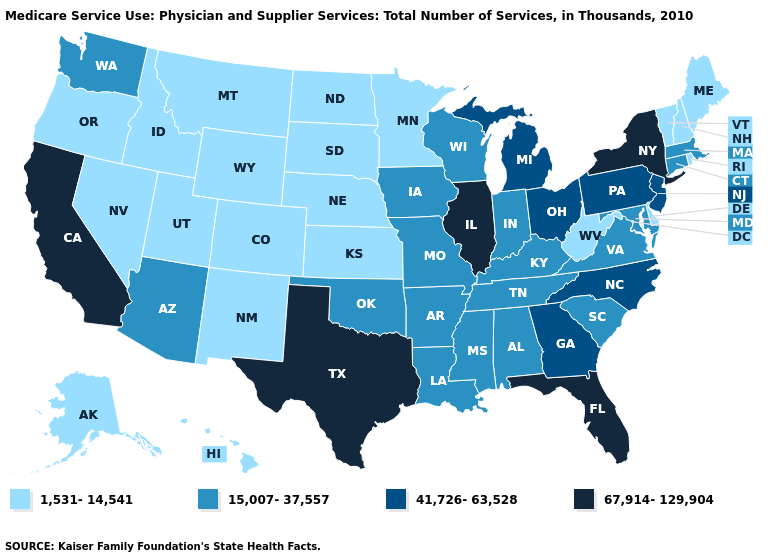What is the value of Missouri?
Write a very short answer. 15,007-37,557. Name the states that have a value in the range 15,007-37,557?
Concise answer only. Alabama, Arizona, Arkansas, Connecticut, Indiana, Iowa, Kentucky, Louisiana, Maryland, Massachusetts, Mississippi, Missouri, Oklahoma, South Carolina, Tennessee, Virginia, Washington, Wisconsin. Does the map have missing data?
Short answer required. No. Name the states that have a value in the range 41,726-63,528?
Answer briefly. Georgia, Michigan, New Jersey, North Carolina, Ohio, Pennsylvania. What is the value of Maryland?
Answer briefly. 15,007-37,557. What is the value of North Dakota?
Quick response, please. 1,531-14,541. Name the states that have a value in the range 15,007-37,557?
Short answer required. Alabama, Arizona, Arkansas, Connecticut, Indiana, Iowa, Kentucky, Louisiana, Maryland, Massachusetts, Mississippi, Missouri, Oklahoma, South Carolina, Tennessee, Virginia, Washington, Wisconsin. Among the states that border Georgia , which have the highest value?
Be succinct. Florida. Is the legend a continuous bar?
Give a very brief answer. No. Which states have the highest value in the USA?
Quick response, please. California, Florida, Illinois, New York, Texas. Among the states that border New Hampshire , does Massachusetts have the lowest value?
Short answer required. No. What is the value of North Dakota?
Quick response, please. 1,531-14,541. Among the states that border Indiana , does Kentucky have the highest value?
Concise answer only. No. What is the lowest value in the MidWest?
Write a very short answer. 1,531-14,541. Among the states that border Tennessee , which have the highest value?
Quick response, please. Georgia, North Carolina. 